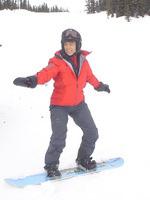Is the person sad?
Be succinct. No. What is the person riding?
Short answer required. Snowboard. Is it cold out?
Give a very brief answer. Yes. 